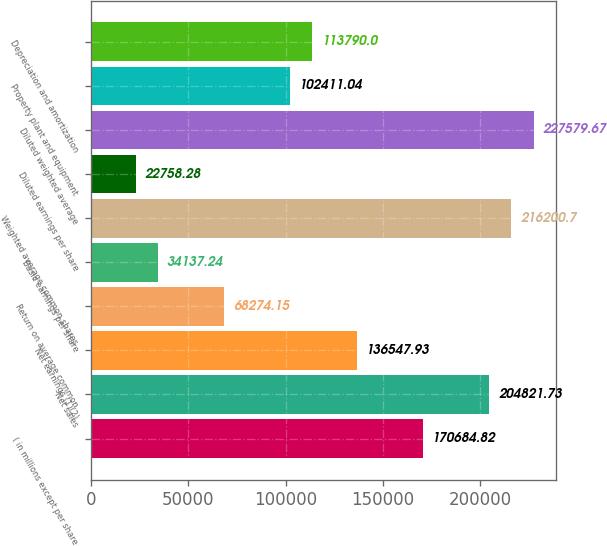Convert chart to OTSL. <chart><loc_0><loc_0><loc_500><loc_500><bar_chart><fcel>( in millions except per share<fcel>Net sales<fcel>Net earnings (1)(2)<fcel>Return on average common<fcel>Basic earnings per share<fcel>Weighted average common shares<fcel>Diluted earnings per share<fcel>Diluted weighted average<fcel>Property plant and equipment<fcel>Depreciation and amortization<nl><fcel>170685<fcel>204822<fcel>136548<fcel>68274.1<fcel>34137.2<fcel>216201<fcel>22758.3<fcel>227580<fcel>102411<fcel>113790<nl></chart> 